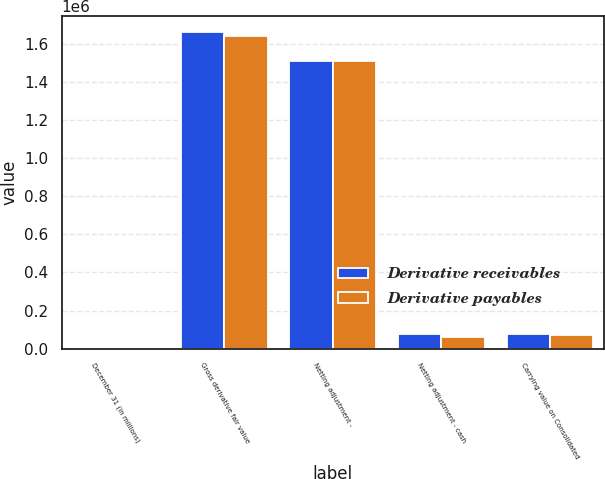Convert chart. <chart><loc_0><loc_0><loc_500><loc_500><stacked_bar_chart><ecel><fcel>December 31 (in millions)<fcel>Gross derivative fair value<fcel>Netting adjustment -<fcel>Netting adjustment - cash<fcel>Carrying value on Consolidated<nl><fcel>Derivative receivables<fcel>2012<fcel>1.66238e+06<fcel>1.50824e+06<fcel>79153<fcel>74983<nl><fcel>Derivative payables<fcel>2012<fcel>1.63956e+06<fcel>1.50824e+06<fcel>60658<fcel>70656<nl></chart> 